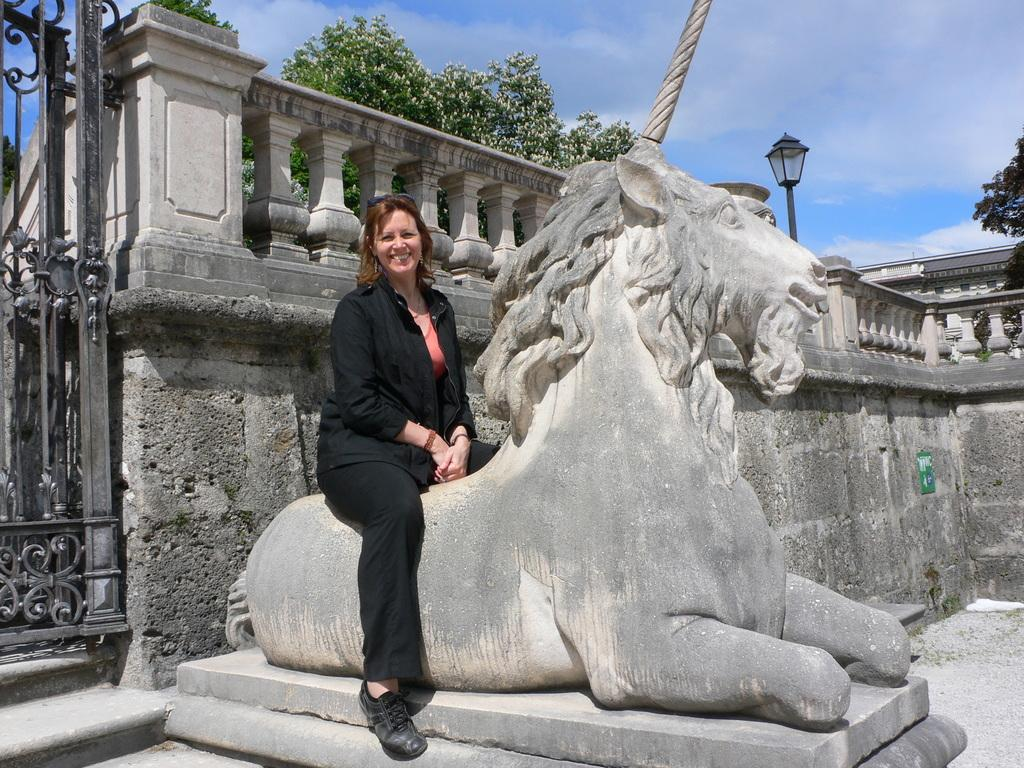What is the woman doing in the image? The woman is sitting on a statue in the image. Can you describe the statue's location? The statue is on a platform. What can be seen in the background of the image? There is a wall, a light, trees, and the sky visible in the background of the image. How many women are walking on the tramp in the image? There is no tramp or women walking in the image; it features a woman sitting on a statue. 